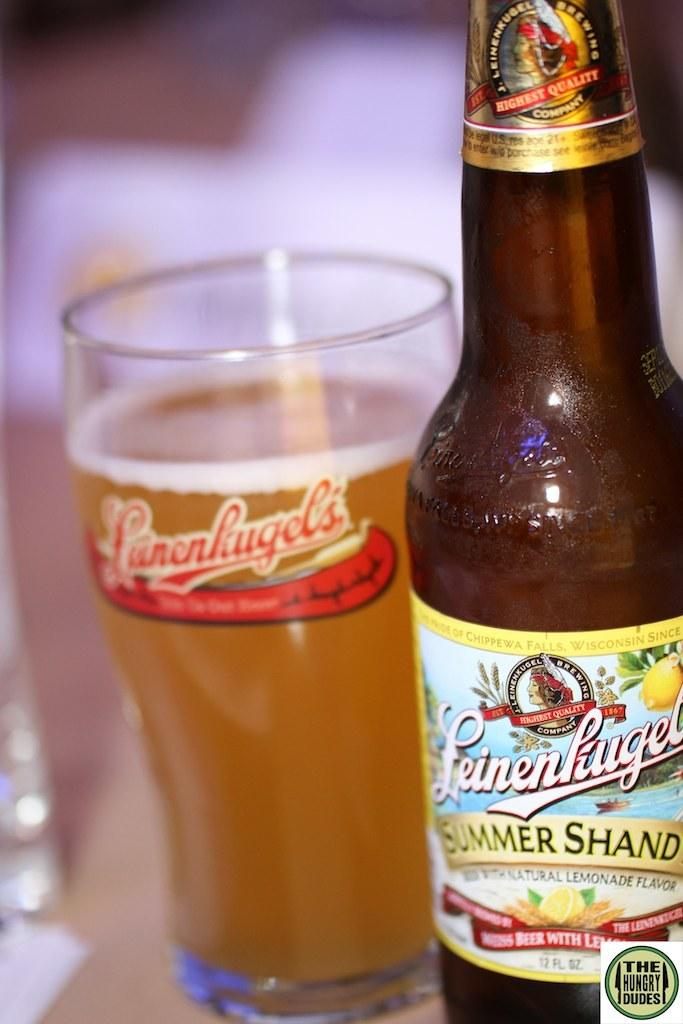Provide a one-sentence caption for the provided image. A Leienhugels summer shand beer bottle next to a filled Leinenhugel's glass. 